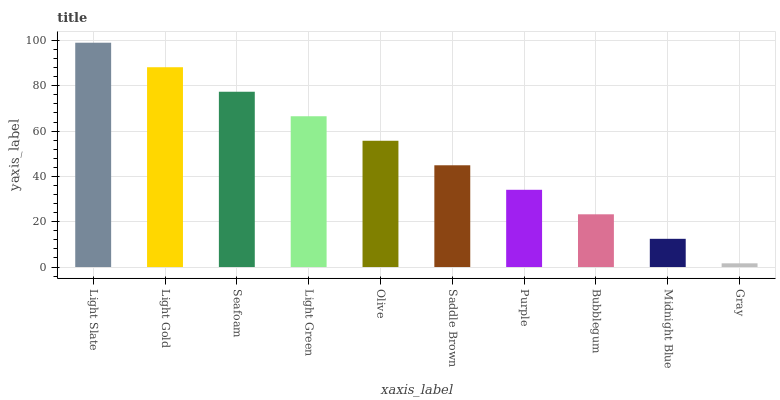Is Gray the minimum?
Answer yes or no. Yes. Is Light Slate the maximum?
Answer yes or no. Yes. Is Light Gold the minimum?
Answer yes or no. No. Is Light Gold the maximum?
Answer yes or no. No. Is Light Slate greater than Light Gold?
Answer yes or no. Yes. Is Light Gold less than Light Slate?
Answer yes or no. Yes. Is Light Gold greater than Light Slate?
Answer yes or no. No. Is Light Slate less than Light Gold?
Answer yes or no. No. Is Olive the high median?
Answer yes or no. Yes. Is Saddle Brown the low median?
Answer yes or no. Yes. Is Light Gold the high median?
Answer yes or no. No. Is Gray the low median?
Answer yes or no. No. 